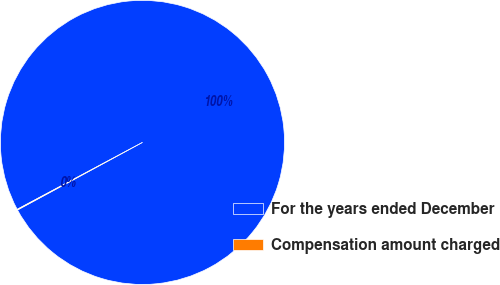<chart> <loc_0><loc_0><loc_500><loc_500><pie_chart><fcel>For the years ended December<fcel>Compensation amount charged<nl><fcel>99.92%<fcel>0.08%<nl></chart> 